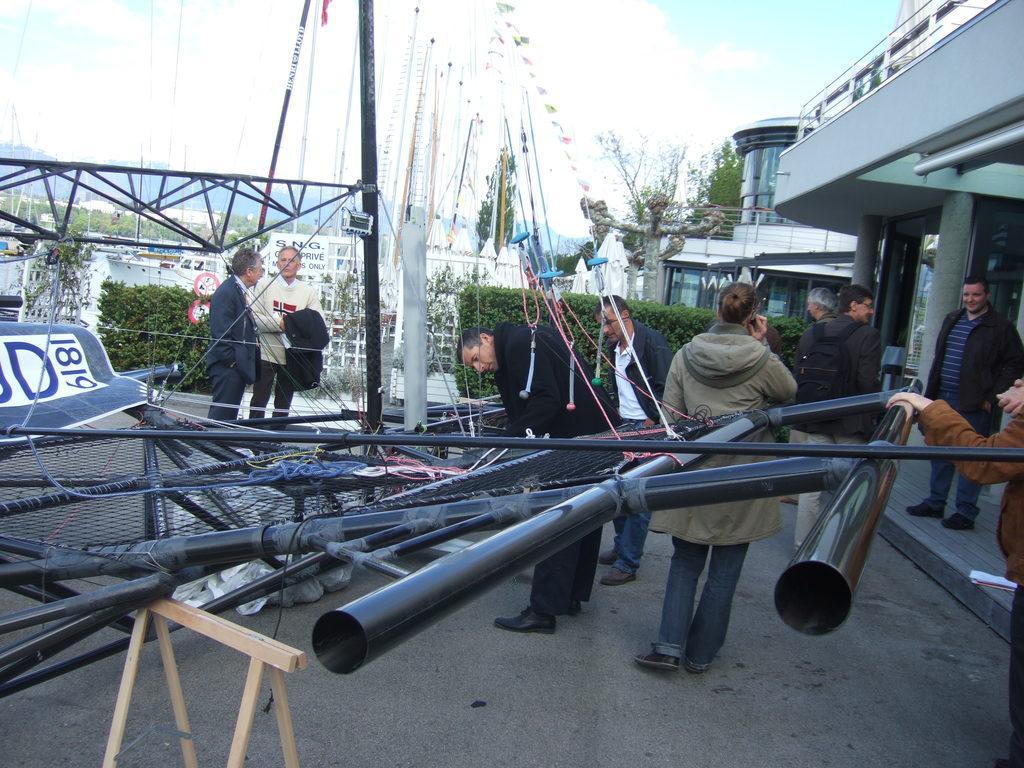Can you describe this image briefly? In this image, we can see a mesh and there are rods. In the background, there are people and we can see poles, flags, buildings, trees and we can see some boards. At the bottom, there is road and at the top, there is sky. 